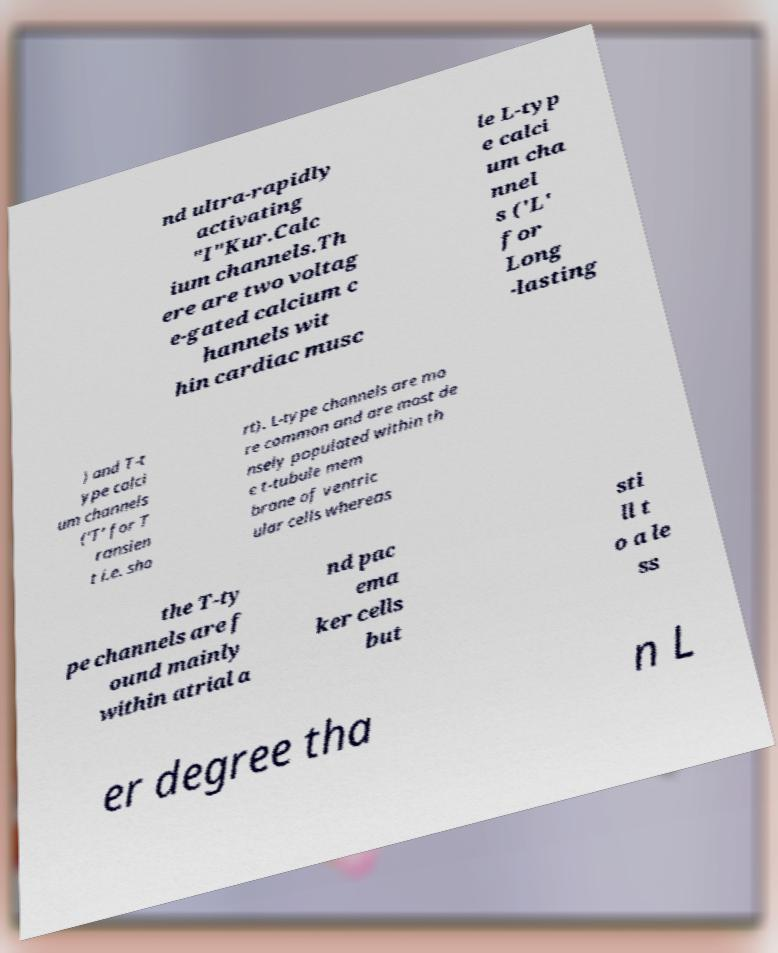Please identify and transcribe the text found in this image. nd ultra-rapidly activating "I"Kur.Calc ium channels.Th ere are two voltag e-gated calcium c hannels wit hin cardiac musc le L-typ e calci um cha nnel s ('L' for Long -lasting ) and T-t ype calci um channels ('T' for T ransien t i.e. sho rt). L-type channels are mo re common and are most de nsely populated within th e t-tubule mem brane of ventric ular cells whereas the T-ty pe channels are f ound mainly within atrial a nd pac ema ker cells but sti ll t o a le ss er degree tha n L 